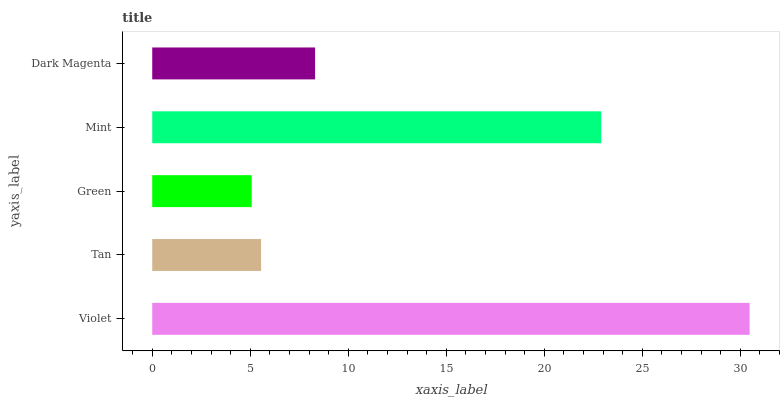Is Green the minimum?
Answer yes or no. Yes. Is Violet the maximum?
Answer yes or no. Yes. Is Tan the minimum?
Answer yes or no. No. Is Tan the maximum?
Answer yes or no. No. Is Violet greater than Tan?
Answer yes or no. Yes. Is Tan less than Violet?
Answer yes or no. Yes. Is Tan greater than Violet?
Answer yes or no. No. Is Violet less than Tan?
Answer yes or no. No. Is Dark Magenta the high median?
Answer yes or no. Yes. Is Dark Magenta the low median?
Answer yes or no. Yes. Is Tan the high median?
Answer yes or no. No. Is Mint the low median?
Answer yes or no. No. 